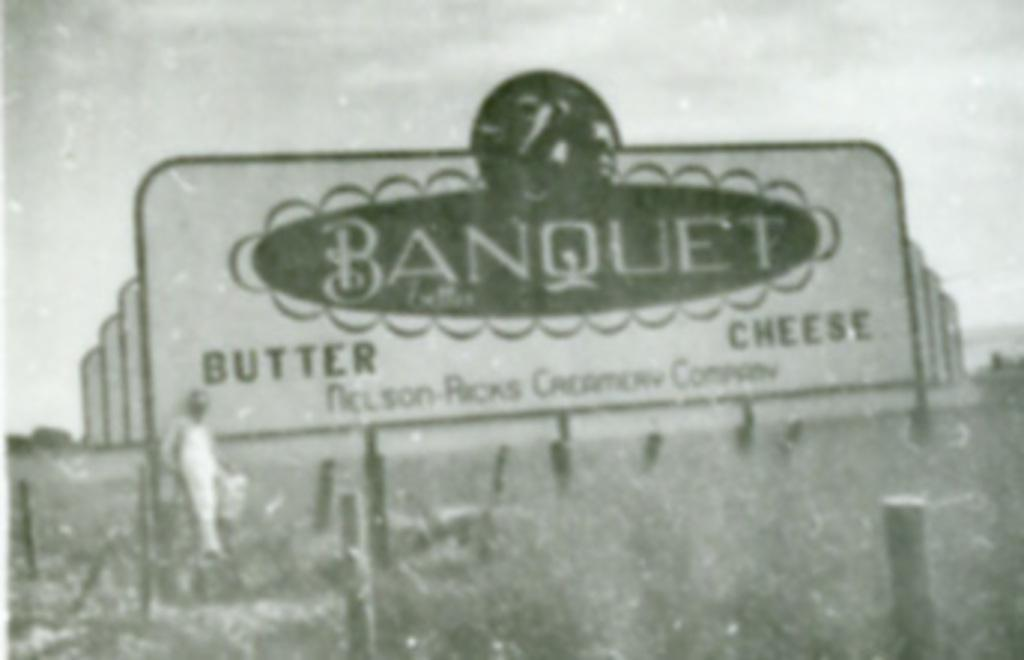What is the overall quality of the image? The image is blurry. What can be seen on the hoarding in the image? The content of the hoarding is not clear due to the blurriness of the image. Can you identify any people in the image? Yes, there is a person in the image. What other objects are present in the image? There are poles in the image. What is visible in the background of the image? The sky is visible in the background of the image. What type of debt is the person in the image facing? There is no information about the person's debt in the image. How does the person's anger manifest in the image? There is no indication of anger in the image. 